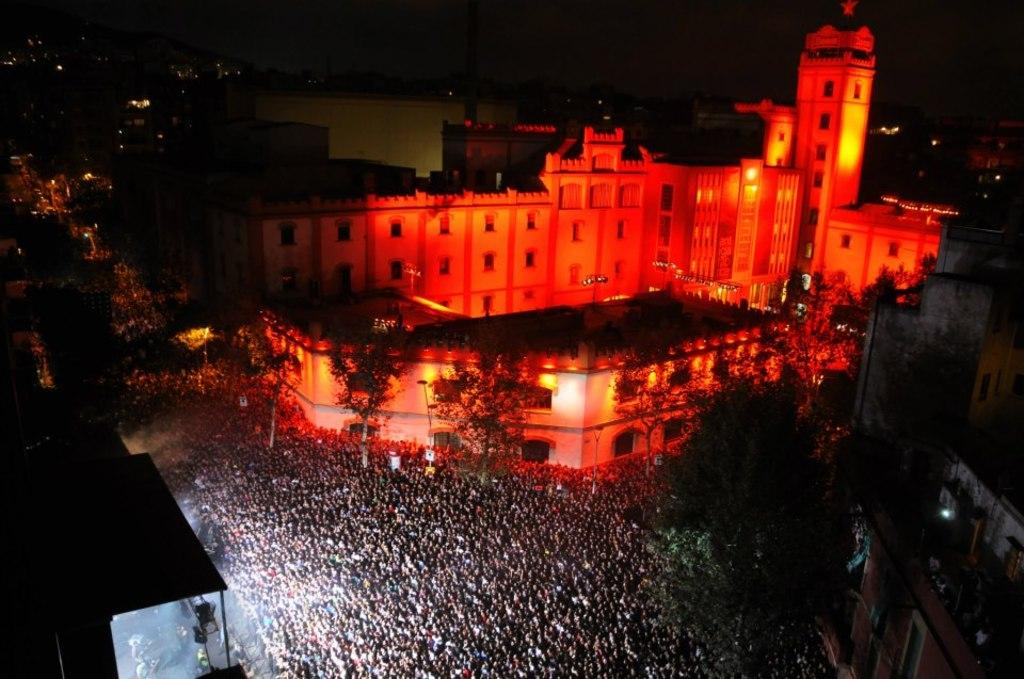What type of structures can be seen in the image? There are buildings in the image. What feature is visible on the buildings? There are windows visible in the image. What type of vegetation is present in the image? There are trees in the image. Can you describe the people in the image? There is a group of people in the image. How would you describe the lighting in the image? The image is dark. What type of brick is being used to bait the fish in the image? There is no brick or fishing activity present in the image. 